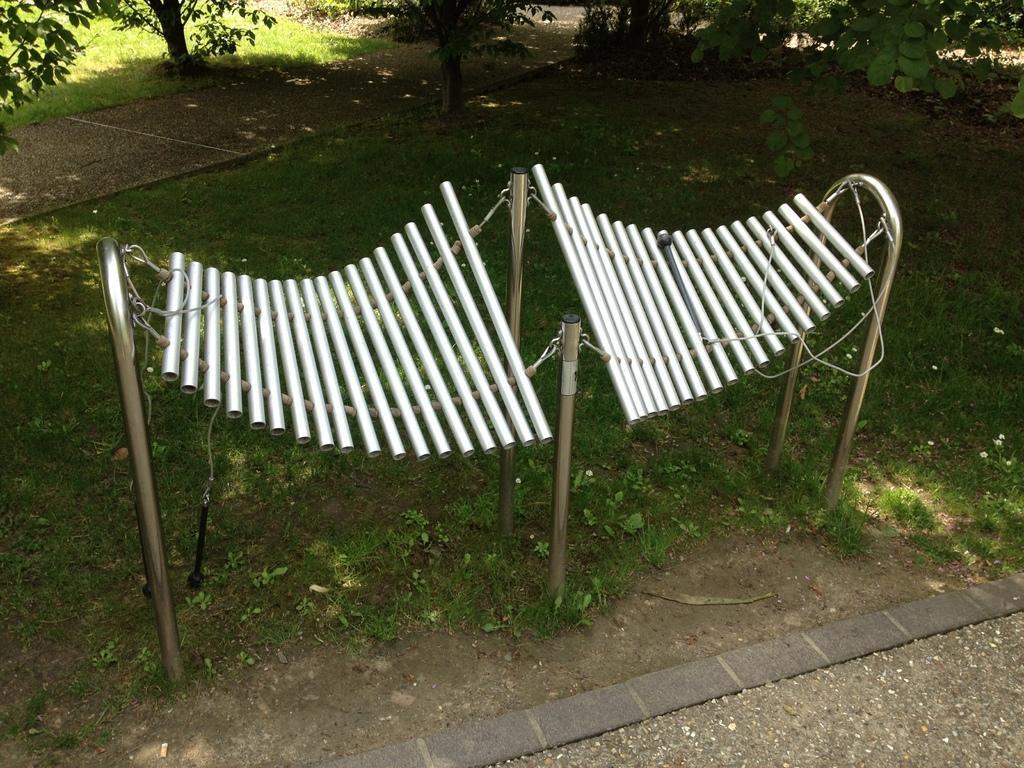Describe this image in one or two sentences. In the center of the image we can see a musical instrument. In the background of the image grass is there. At the top of the image some plants are there. At the bottom of the image ground is there. 